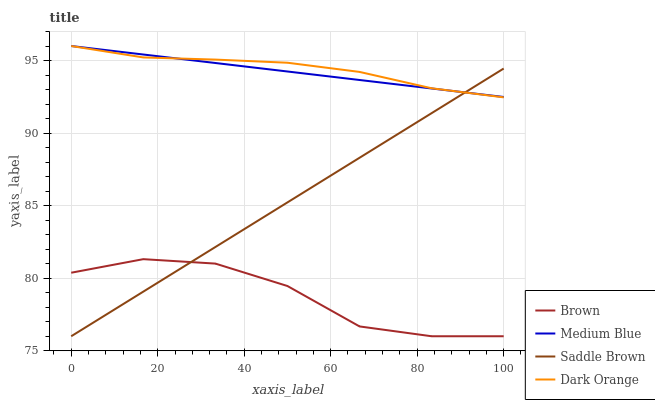Does Brown have the minimum area under the curve?
Answer yes or no. Yes. Does Dark Orange have the maximum area under the curve?
Answer yes or no. Yes. Does Medium Blue have the minimum area under the curve?
Answer yes or no. No. Does Medium Blue have the maximum area under the curve?
Answer yes or no. No. Is Medium Blue the smoothest?
Answer yes or no. Yes. Is Brown the roughest?
Answer yes or no. Yes. Is Saddle Brown the smoothest?
Answer yes or no. No. Is Saddle Brown the roughest?
Answer yes or no. No. Does Brown have the lowest value?
Answer yes or no. Yes. Does Medium Blue have the lowest value?
Answer yes or no. No. Does Dark Orange have the highest value?
Answer yes or no. Yes. Does Saddle Brown have the highest value?
Answer yes or no. No. Is Brown less than Medium Blue?
Answer yes or no. Yes. Is Dark Orange greater than Brown?
Answer yes or no. Yes. Does Saddle Brown intersect Dark Orange?
Answer yes or no. Yes. Is Saddle Brown less than Dark Orange?
Answer yes or no. No. Is Saddle Brown greater than Dark Orange?
Answer yes or no. No. Does Brown intersect Medium Blue?
Answer yes or no. No. 